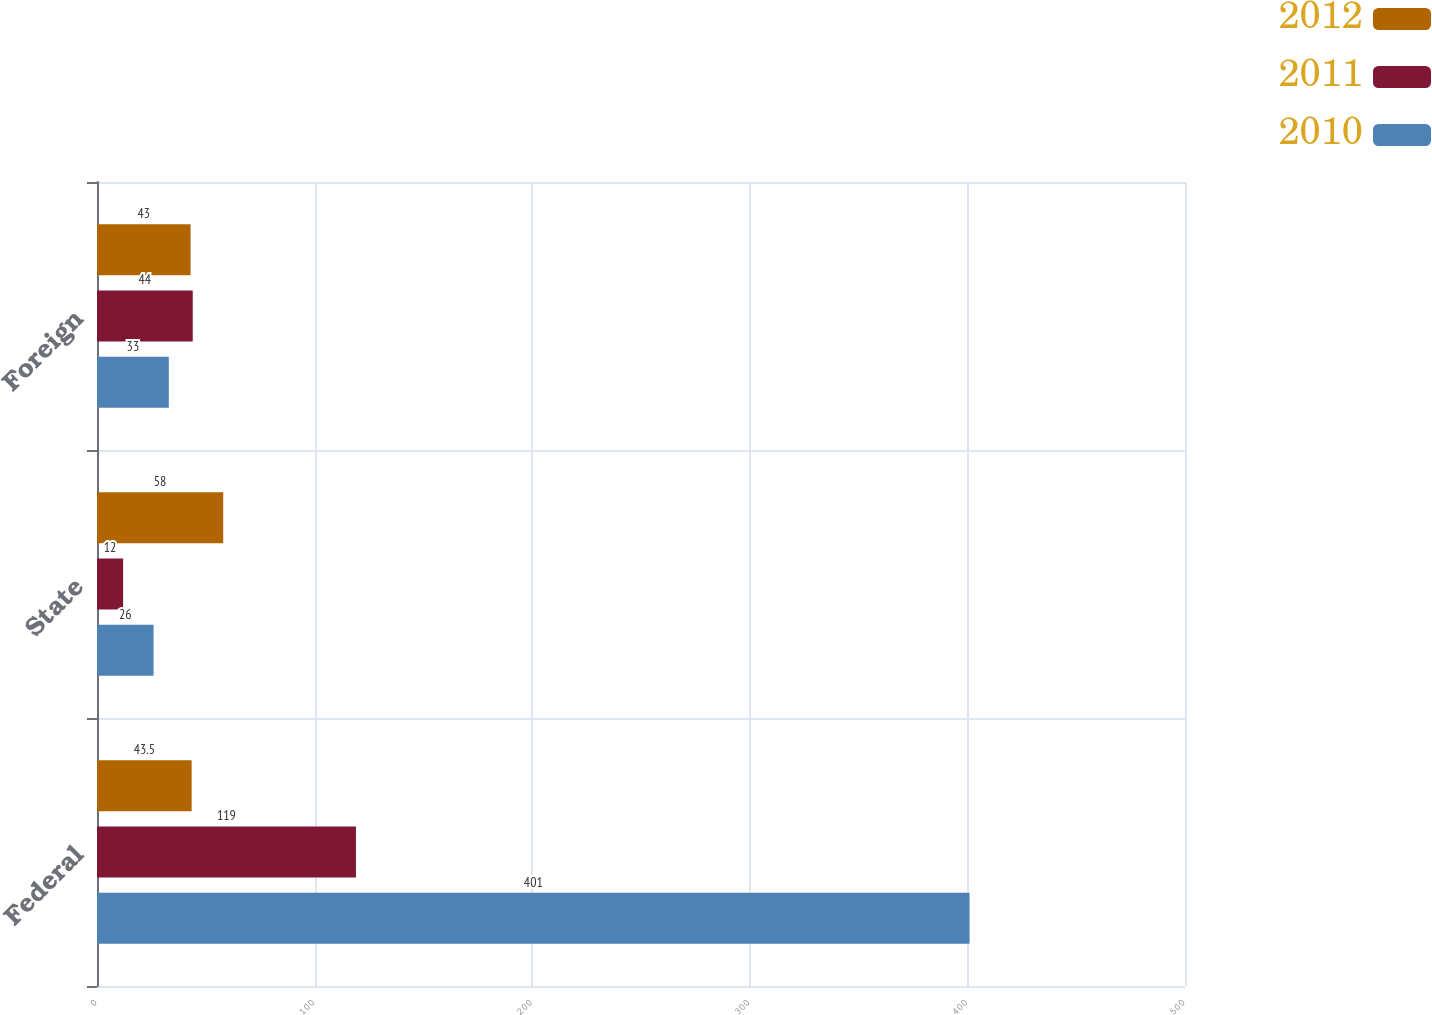<chart> <loc_0><loc_0><loc_500><loc_500><stacked_bar_chart><ecel><fcel>Federal<fcel>State<fcel>Foreign<nl><fcel>2012<fcel>43.5<fcel>58<fcel>43<nl><fcel>2011<fcel>119<fcel>12<fcel>44<nl><fcel>2010<fcel>401<fcel>26<fcel>33<nl></chart> 